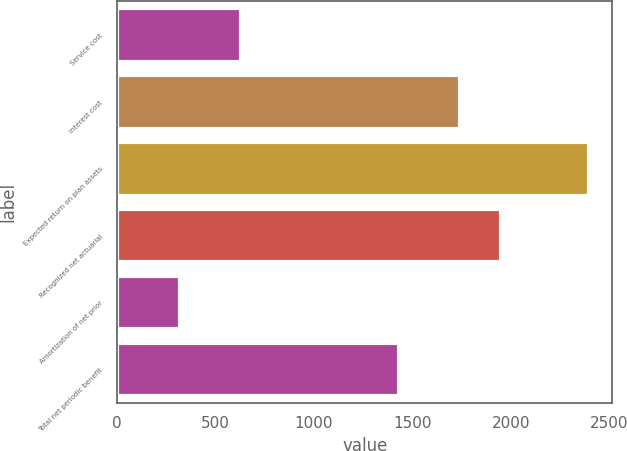<chart> <loc_0><loc_0><loc_500><loc_500><bar_chart><fcel>Service cost<fcel>Interest cost<fcel>Expected return on plan assets<fcel>Recognized net actuarial<fcel>Amortization of net prior<fcel>Total net periodic benefit<nl><fcel>630<fcel>1740<fcel>2395<fcel>1947.4<fcel>321<fcel>1431<nl></chart> 